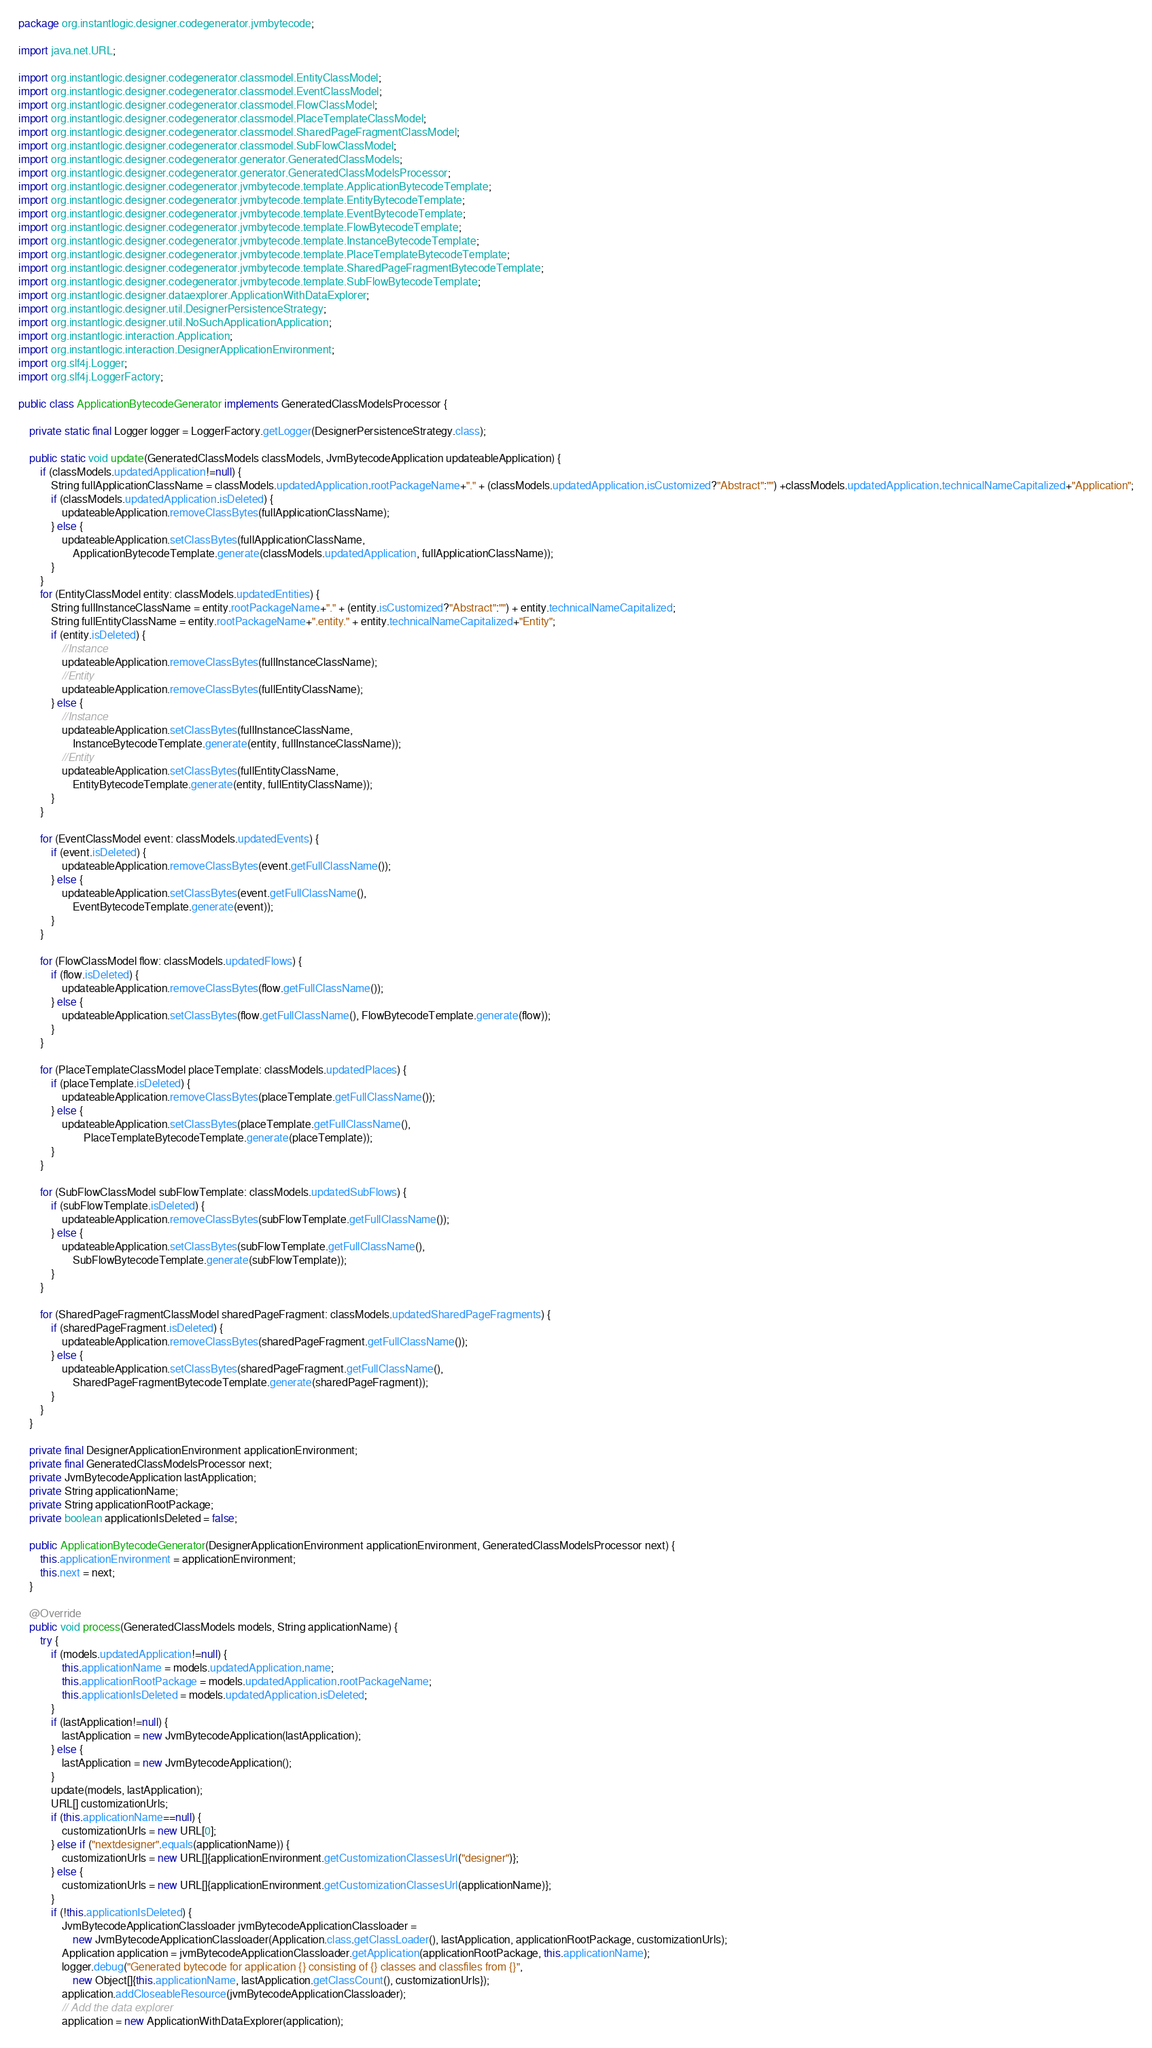Convert code to text. <code><loc_0><loc_0><loc_500><loc_500><_Java_>package org.instantlogic.designer.codegenerator.jvmbytecode;

import java.net.URL;

import org.instantlogic.designer.codegenerator.classmodel.EntityClassModel;
import org.instantlogic.designer.codegenerator.classmodel.EventClassModel;
import org.instantlogic.designer.codegenerator.classmodel.FlowClassModel;
import org.instantlogic.designer.codegenerator.classmodel.PlaceTemplateClassModel;
import org.instantlogic.designer.codegenerator.classmodel.SharedPageFragmentClassModel;
import org.instantlogic.designer.codegenerator.classmodel.SubFlowClassModel;
import org.instantlogic.designer.codegenerator.generator.GeneratedClassModels;
import org.instantlogic.designer.codegenerator.generator.GeneratedClassModelsProcessor;
import org.instantlogic.designer.codegenerator.jvmbytecode.template.ApplicationBytecodeTemplate;
import org.instantlogic.designer.codegenerator.jvmbytecode.template.EntityBytecodeTemplate;
import org.instantlogic.designer.codegenerator.jvmbytecode.template.EventBytecodeTemplate;
import org.instantlogic.designer.codegenerator.jvmbytecode.template.FlowBytecodeTemplate;
import org.instantlogic.designer.codegenerator.jvmbytecode.template.InstanceBytecodeTemplate;
import org.instantlogic.designer.codegenerator.jvmbytecode.template.PlaceTemplateBytecodeTemplate;
import org.instantlogic.designer.codegenerator.jvmbytecode.template.SharedPageFragmentBytecodeTemplate;
import org.instantlogic.designer.codegenerator.jvmbytecode.template.SubFlowBytecodeTemplate;
import org.instantlogic.designer.dataexplorer.ApplicationWithDataExplorer;
import org.instantlogic.designer.util.DesignerPersistenceStrategy;
import org.instantlogic.designer.util.NoSuchApplicationApplication;
import org.instantlogic.interaction.Application;
import org.instantlogic.interaction.DesignerApplicationEnvironment;
import org.slf4j.Logger;
import org.slf4j.LoggerFactory;

public class ApplicationBytecodeGenerator implements GeneratedClassModelsProcessor {

	private static final Logger logger = LoggerFactory.getLogger(DesignerPersistenceStrategy.class);

	public static void update(GeneratedClassModels classModels, JvmBytecodeApplication updateableApplication) {
		if (classModels.updatedApplication!=null) {
			String fullApplicationClassName = classModels.updatedApplication.rootPackageName+"." + (classModels.updatedApplication.isCustomized?"Abstract":"") +classModels.updatedApplication.technicalNameCapitalized+"Application";
			if (classModels.updatedApplication.isDeleted) {
				updateableApplication.removeClassBytes(fullApplicationClassName);
			} else {
				updateableApplication.setClassBytes(fullApplicationClassName,
					ApplicationBytecodeTemplate.generate(classModels.updatedApplication, fullApplicationClassName));
			}
		}
		for (EntityClassModel entity: classModels.updatedEntities) {
			String fullInstanceClassName = entity.rootPackageName+"." + (entity.isCustomized?"Abstract":"") + entity.technicalNameCapitalized;
			String fullEntityClassName = entity.rootPackageName+".entity." + entity.technicalNameCapitalized+"Entity";
			if (entity.isDeleted) {
				//Instance
				updateableApplication.removeClassBytes(fullInstanceClassName);
				//Entity
				updateableApplication.removeClassBytes(fullEntityClassName);
			} else {
				//Instance
				updateableApplication.setClassBytes(fullInstanceClassName,
					InstanceBytecodeTemplate.generate(entity, fullInstanceClassName));
				//Entity
				updateableApplication.setClassBytes(fullEntityClassName,
					EntityBytecodeTemplate.generate(entity, fullEntityClassName));
			}
		}

		for (EventClassModel event: classModels.updatedEvents) {
			if (event.isDeleted) {
				updateableApplication.removeClassBytes(event.getFullClassName());
			} else {
				updateableApplication.setClassBytes(event.getFullClassName(),
					EventBytecodeTemplate.generate(event));
			}
		}
		
		for (FlowClassModel flow: classModels.updatedFlows) {
			if (flow.isDeleted) {
				updateableApplication.removeClassBytes(flow.getFullClassName());
			} else {
				updateableApplication.setClassBytes(flow.getFullClassName(), FlowBytecodeTemplate.generate(flow));
			}
		}
		
		for (PlaceTemplateClassModel placeTemplate: classModels.updatedPlaces) {
			if (placeTemplate.isDeleted) {
				updateableApplication.removeClassBytes(placeTemplate.getFullClassName());
			} else {
				updateableApplication.setClassBytes(placeTemplate.getFullClassName(),
						PlaceTemplateBytecodeTemplate.generate(placeTemplate));
			}
		}

		for (SubFlowClassModel subFlowTemplate: classModels.updatedSubFlows) {
			if (subFlowTemplate.isDeleted) {
				updateableApplication.removeClassBytes(subFlowTemplate.getFullClassName());
			} else {
				updateableApplication.setClassBytes(subFlowTemplate.getFullClassName(),
					SubFlowBytecodeTemplate.generate(subFlowTemplate));
			}
		}
		
		for (SharedPageFragmentClassModel sharedPageFragment: classModels.updatedSharedPageFragments) {
			if (sharedPageFragment.isDeleted) {
				updateableApplication.removeClassBytes(sharedPageFragment.getFullClassName());
			} else {
				updateableApplication.setClassBytes(sharedPageFragment.getFullClassName(),
					SharedPageFragmentBytecodeTemplate.generate(sharedPageFragment));
			}
		}
	}
	
	private final DesignerApplicationEnvironment applicationEnvironment;
	private final GeneratedClassModelsProcessor next;
	private JvmBytecodeApplication lastApplication;
	private String applicationName;
	private String applicationRootPackage;
	private boolean applicationIsDeleted = false;
	
	public ApplicationBytecodeGenerator(DesignerApplicationEnvironment applicationEnvironment, GeneratedClassModelsProcessor next) {
		this.applicationEnvironment = applicationEnvironment;
		this.next = next;
	}

	@Override
	public void process(GeneratedClassModels models, String applicationName) {
		try {
			if (models.updatedApplication!=null) {
				this.applicationName = models.updatedApplication.name;
				this.applicationRootPackage = models.updatedApplication.rootPackageName;
				this.applicationIsDeleted = models.updatedApplication.isDeleted;
			}
			if (lastApplication!=null) {
				lastApplication = new JvmBytecodeApplication(lastApplication);
			} else {
				lastApplication = new JvmBytecodeApplication();
			}
			update(models, lastApplication);
			URL[] customizationUrls;
			if (this.applicationName==null) {
				customizationUrls = new URL[0];
			} else if ("nextdesigner".equals(applicationName)) {
				customizationUrls = new URL[]{applicationEnvironment.getCustomizationClassesUrl("designer")};
			} else {
				customizationUrls = new URL[]{applicationEnvironment.getCustomizationClassesUrl(applicationName)};
			}
			if (!this.applicationIsDeleted) {
				JvmBytecodeApplicationClassloader jvmBytecodeApplicationClassloader = 
					new JvmBytecodeApplicationClassloader(Application.class.getClassLoader(), lastApplication, applicationRootPackage, customizationUrls);
				Application application = jvmBytecodeApplicationClassloader.getApplication(applicationRootPackage, this.applicationName);
				logger.debug("Generated bytecode for application {} consisting of {} classes and classfiles from {}", 
					new Object[]{this.applicationName, lastApplication.getClassCount(), customizationUrls});
				application.addCloseableResource(jvmBytecodeApplicationClassloader);
				// Add the data explorer
				application = new ApplicationWithDataExplorer(application);</code> 